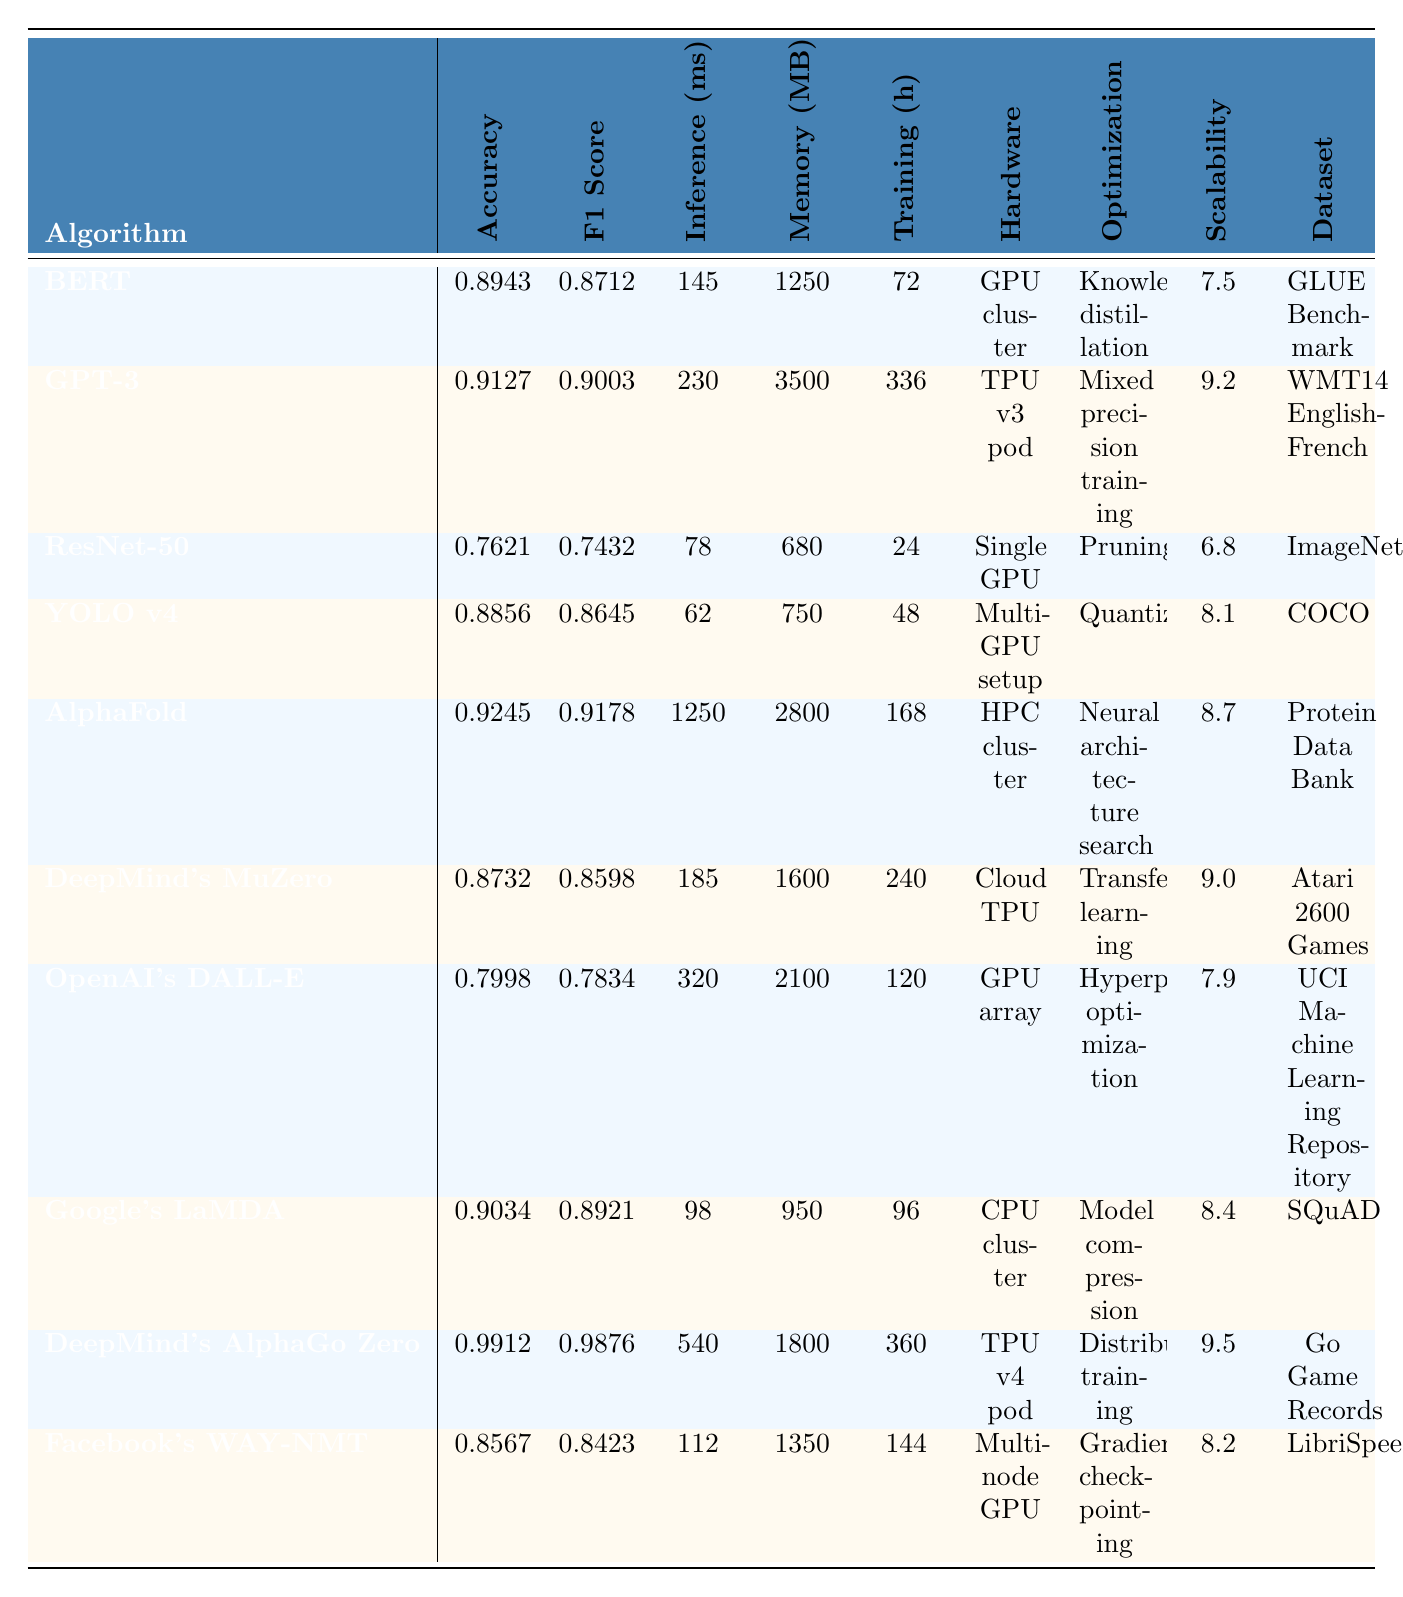What is the accuracy of GPT-3? The accuracy of GPT-3 is listed directly in the table, which shows a value of 0.9127.
Answer: 0.9127 Which algorithm has the lowest F1 score? The F1 scores of all algorithms are given in the table. By comparing them, ResNet-50 has the lowest F1 score of 0.7432.
Answer: ResNet-50 What is the difference in inference time between YOLO v4 and AlphaFold? YOLO v4 has an inference time of 62 ms, while AlphaFold has an inference time of 1250 ms. The difference is calculated as 1250 - 62 = 1188 ms.
Answer: 1188 ms Is it true that OpenAI's DALL-E uses a GPU array for hardware requirements? The table indicates that OpenAI's DALL-E indeed uses a GPU array, confirming the statement is true.
Answer: Yes What is the average memory usage of the algorithms listed in the table? To find the average, sum the memory usages: (1250 + 3500 + 680 + 750 + 2800 + 1600 + 2100 + 950 + 1800 + 1350) =  11580 MB. There are 10 algorithms, so the average is 11580 / 10 = 1158.
Answer: 1158 MB Which algorithm requires the longest training time, and how long is it? By examining the training times provided in the table, DeepMind's AlphaGo Zero has the longest training time of 360 hours.
Answer: DeepMind's AlphaGo Zero, 360 hours If we consider scalability scores, what is the median value among the algorithms? Sorting the scalability scores: [6.8, 7.5, 7.9, 8.1, 8.2, 8.4, 8.7, 9.0, 9.2, 9.5], the median is the average of the 5th and 6th values, (8.2 + 8.4) / 2 = 8.3.
Answer: 8.3 What is the hardware requirement for the algorithm with the highest accuracy? The highest accuracy is 0.9912 for DeepMind's AlphaGo Zero, which uses a TPU v4 pod as its hardware requirement.
Answer: TPU v4 pod How many algorithms have a memory usage of over 2000 MB? Looking at the memory usage values, there are 4 algorithms (GPT-3, AlphaFold, DeepMind's MuZero, OpenAI's DALL-E) that exceed 2000 MB.
Answer: 4 Which optimization technique is associated with the algorithm that has the second highest F1 score? The algorithm with the second highest F1 score of 0.9003 is GPT-3, which uses mixed precision training as its optimization technique.
Answer: Mixed precision training 